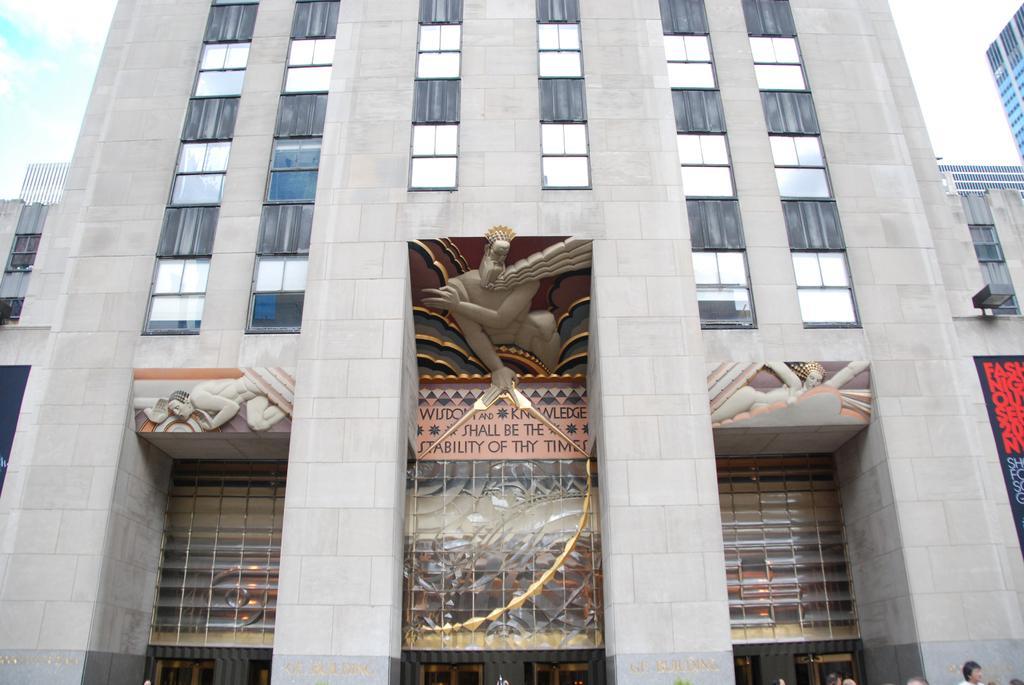Can you describe this image briefly? In this picture I can see there is a building, a statue on the building and the sky is clear. 